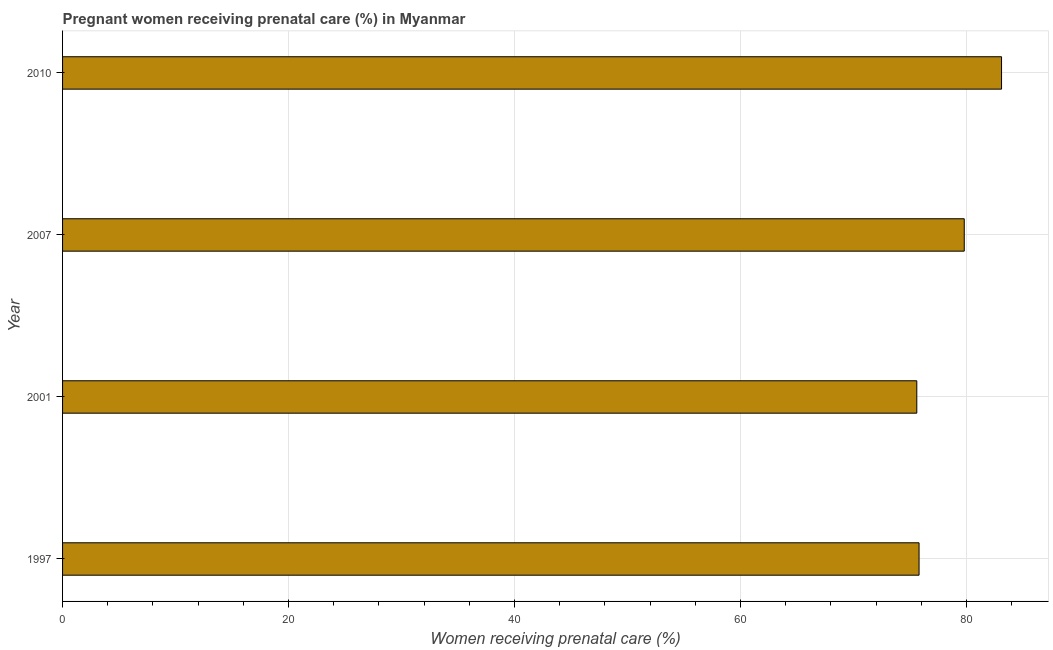What is the title of the graph?
Offer a very short reply. Pregnant women receiving prenatal care (%) in Myanmar. What is the label or title of the X-axis?
Provide a succinct answer. Women receiving prenatal care (%). What is the label or title of the Y-axis?
Offer a terse response. Year. What is the percentage of pregnant women receiving prenatal care in 2001?
Your answer should be compact. 75.6. Across all years, what is the maximum percentage of pregnant women receiving prenatal care?
Offer a terse response. 83.1. Across all years, what is the minimum percentage of pregnant women receiving prenatal care?
Your response must be concise. 75.6. In which year was the percentage of pregnant women receiving prenatal care minimum?
Keep it short and to the point. 2001. What is the sum of the percentage of pregnant women receiving prenatal care?
Make the answer very short. 314.3. What is the difference between the percentage of pregnant women receiving prenatal care in 2007 and 2010?
Your answer should be very brief. -3.3. What is the average percentage of pregnant women receiving prenatal care per year?
Ensure brevity in your answer.  78.58. What is the median percentage of pregnant women receiving prenatal care?
Provide a short and direct response. 77.8. Do a majority of the years between 2001 and 1997 (inclusive) have percentage of pregnant women receiving prenatal care greater than 28 %?
Provide a succinct answer. No. Is the sum of the percentage of pregnant women receiving prenatal care in 1997 and 2007 greater than the maximum percentage of pregnant women receiving prenatal care across all years?
Your answer should be very brief. Yes. What is the difference between the highest and the lowest percentage of pregnant women receiving prenatal care?
Your answer should be compact. 7.5. How many bars are there?
Make the answer very short. 4. How many years are there in the graph?
Give a very brief answer. 4. What is the Women receiving prenatal care (%) of 1997?
Your response must be concise. 75.8. What is the Women receiving prenatal care (%) in 2001?
Your response must be concise. 75.6. What is the Women receiving prenatal care (%) of 2007?
Your answer should be compact. 79.8. What is the Women receiving prenatal care (%) of 2010?
Your response must be concise. 83.1. What is the difference between the Women receiving prenatal care (%) in 1997 and 2007?
Give a very brief answer. -4. What is the difference between the Women receiving prenatal care (%) in 1997 and 2010?
Your answer should be very brief. -7.3. What is the difference between the Women receiving prenatal care (%) in 2001 and 2010?
Give a very brief answer. -7.5. What is the difference between the Women receiving prenatal care (%) in 2007 and 2010?
Your answer should be very brief. -3.3. What is the ratio of the Women receiving prenatal care (%) in 1997 to that in 2001?
Provide a succinct answer. 1. What is the ratio of the Women receiving prenatal care (%) in 1997 to that in 2010?
Your response must be concise. 0.91. What is the ratio of the Women receiving prenatal care (%) in 2001 to that in 2007?
Offer a very short reply. 0.95. What is the ratio of the Women receiving prenatal care (%) in 2001 to that in 2010?
Keep it short and to the point. 0.91. What is the ratio of the Women receiving prenatal care (%) in 2007 to that in 2010?
Keep it short and to the point. 0.96. 